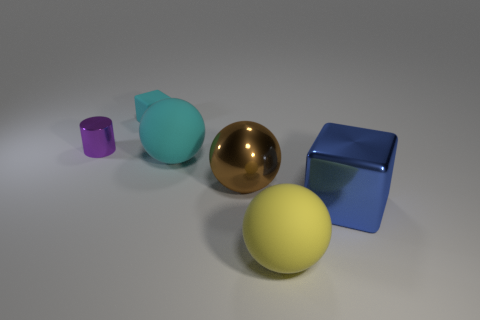There is a block that is in front of the thing that is left of the cyan rubber cube; what is its material?
Give a very brief answer. Metal. What number of shiny spheres are the same color as the metallic cylinder?
Keep it short and to the point. 0. Are there fewer large rubber objects behind the tiny cyan rubber block than small gray rubber blocks?
Keep it short and to the point. No. What is the color of the small thing left of the cube behind the big metal cube?
Your answer should be compact. Purple. There is a block left of the matte ball that is in front of the cyan thing that is right of the cyan matte cube; what is its size?
Provide a succinct answer. Small. Is the number of cyan rubber blocks that are behind the cyan matte block less than the number of large metal things that are on the right side of the yellow sphere?
Make the answer very short. Yes. What number of cylinders have the same material as the small cyan cube?
Provide a short and direct response. 0. Is there a tiny rubber cube that is on the right side of the cyan thing that is right of the matte block behind the small purple cylinder?
Provide a short and direct response. No. What shape is the tiny cyan object that is the same material as the big yellow sphere?
Your answer should be very brief. Cube. Are there more big yellow rubber spheres than big rubber balls?
Offer a very short reply. No. 